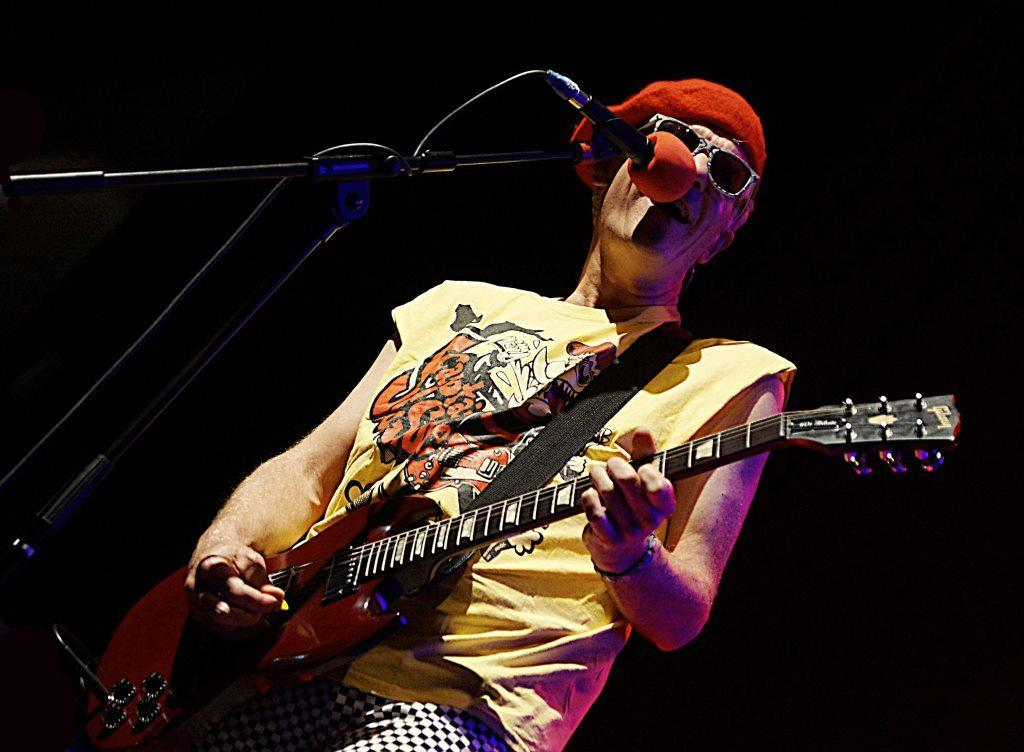Who is the main subject in the image? There is a man in the image. What is the man doing in the image? The man is singing and playing a guitar. What object is present in the image that is typically used for amplifying sound? There is a microphone in the image. How many fish can be seen swimming in the image? There are no fish present in the image. What emotion does the man express towards the sun in the image? The image does not show the man expressing any emotion towards the sun, as there is no sun present in the image. 